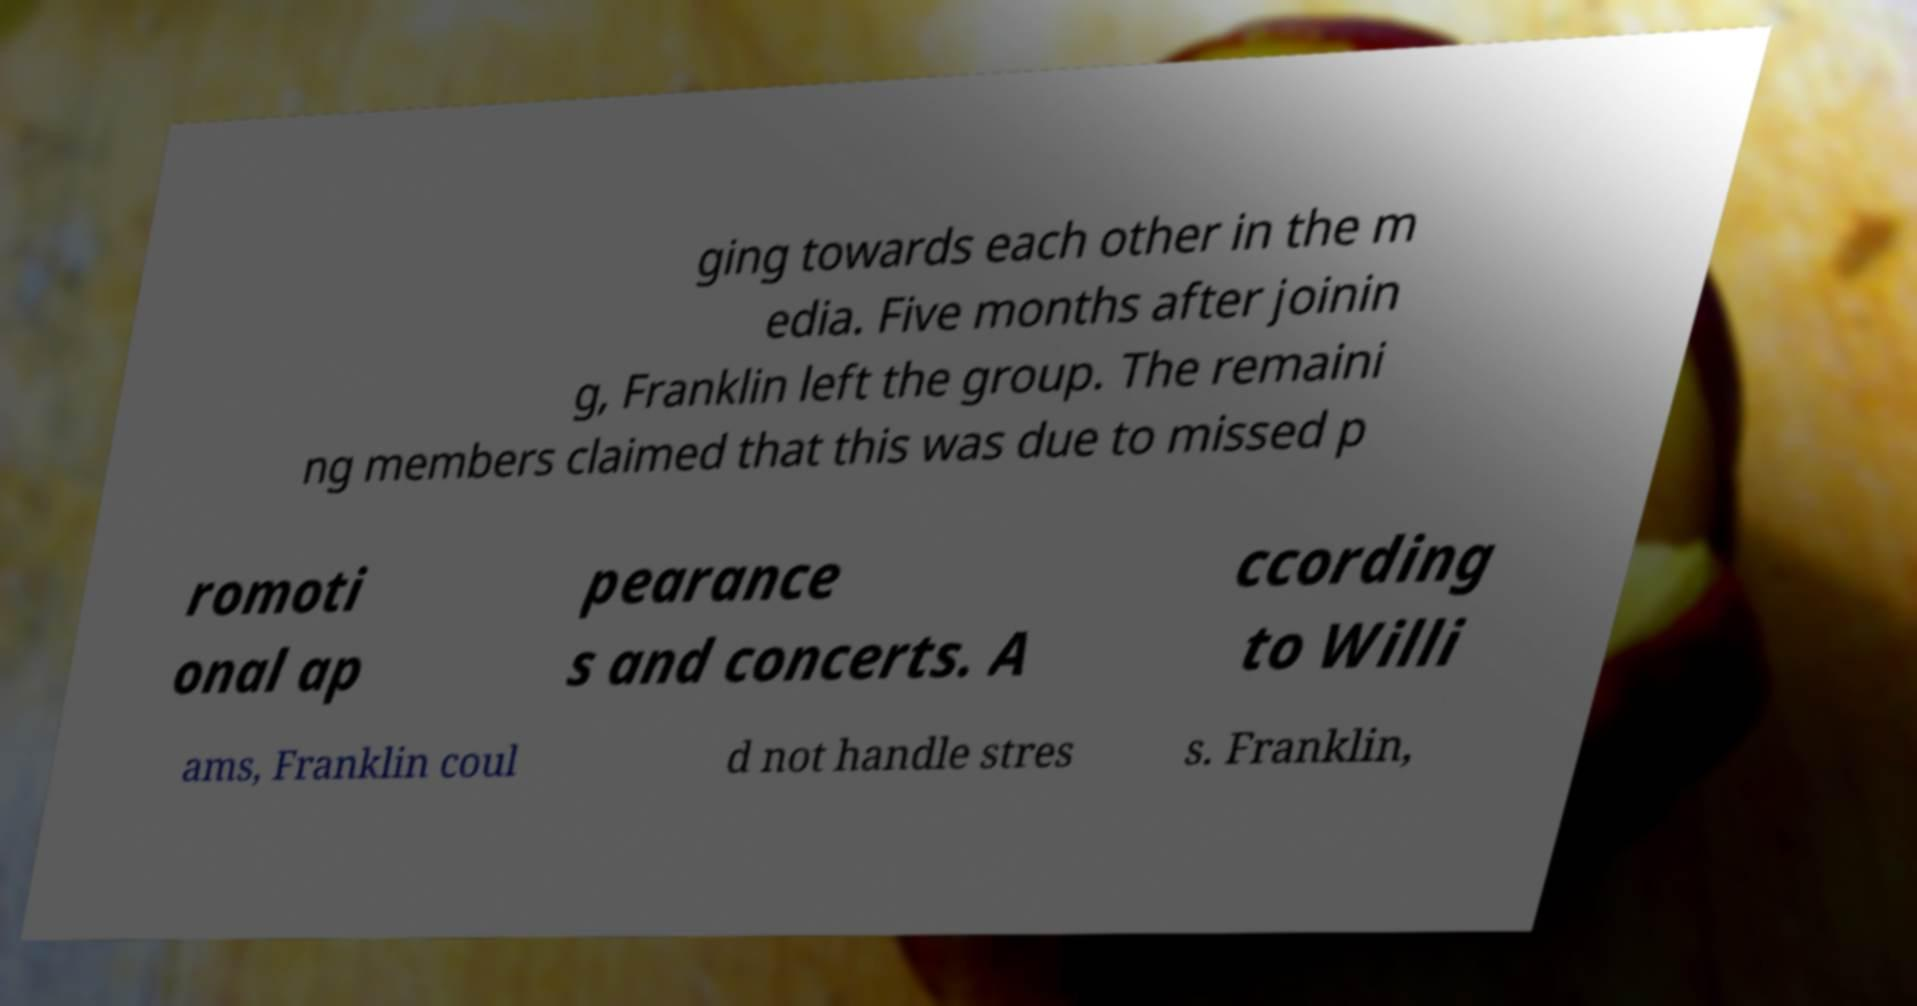For documentation purposes, I need the text within this image transcribed. Could you provide that? ging towards each other in the m edia. Five months after joinin g, Franklin left the group. The remaini ng members claimed that this was due to missed p romoti onal ap pearance s and concerts. A ccording to Willi ams, Franklin coul d not handle stres s. Franklin, 